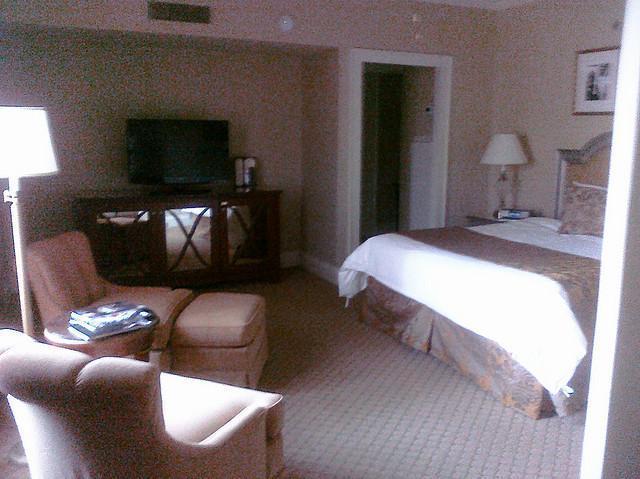How many chairs are in the photo?
Give a very brief answer. 2. How many of the dogs have black spots?
Give a very brief answer. 0. 